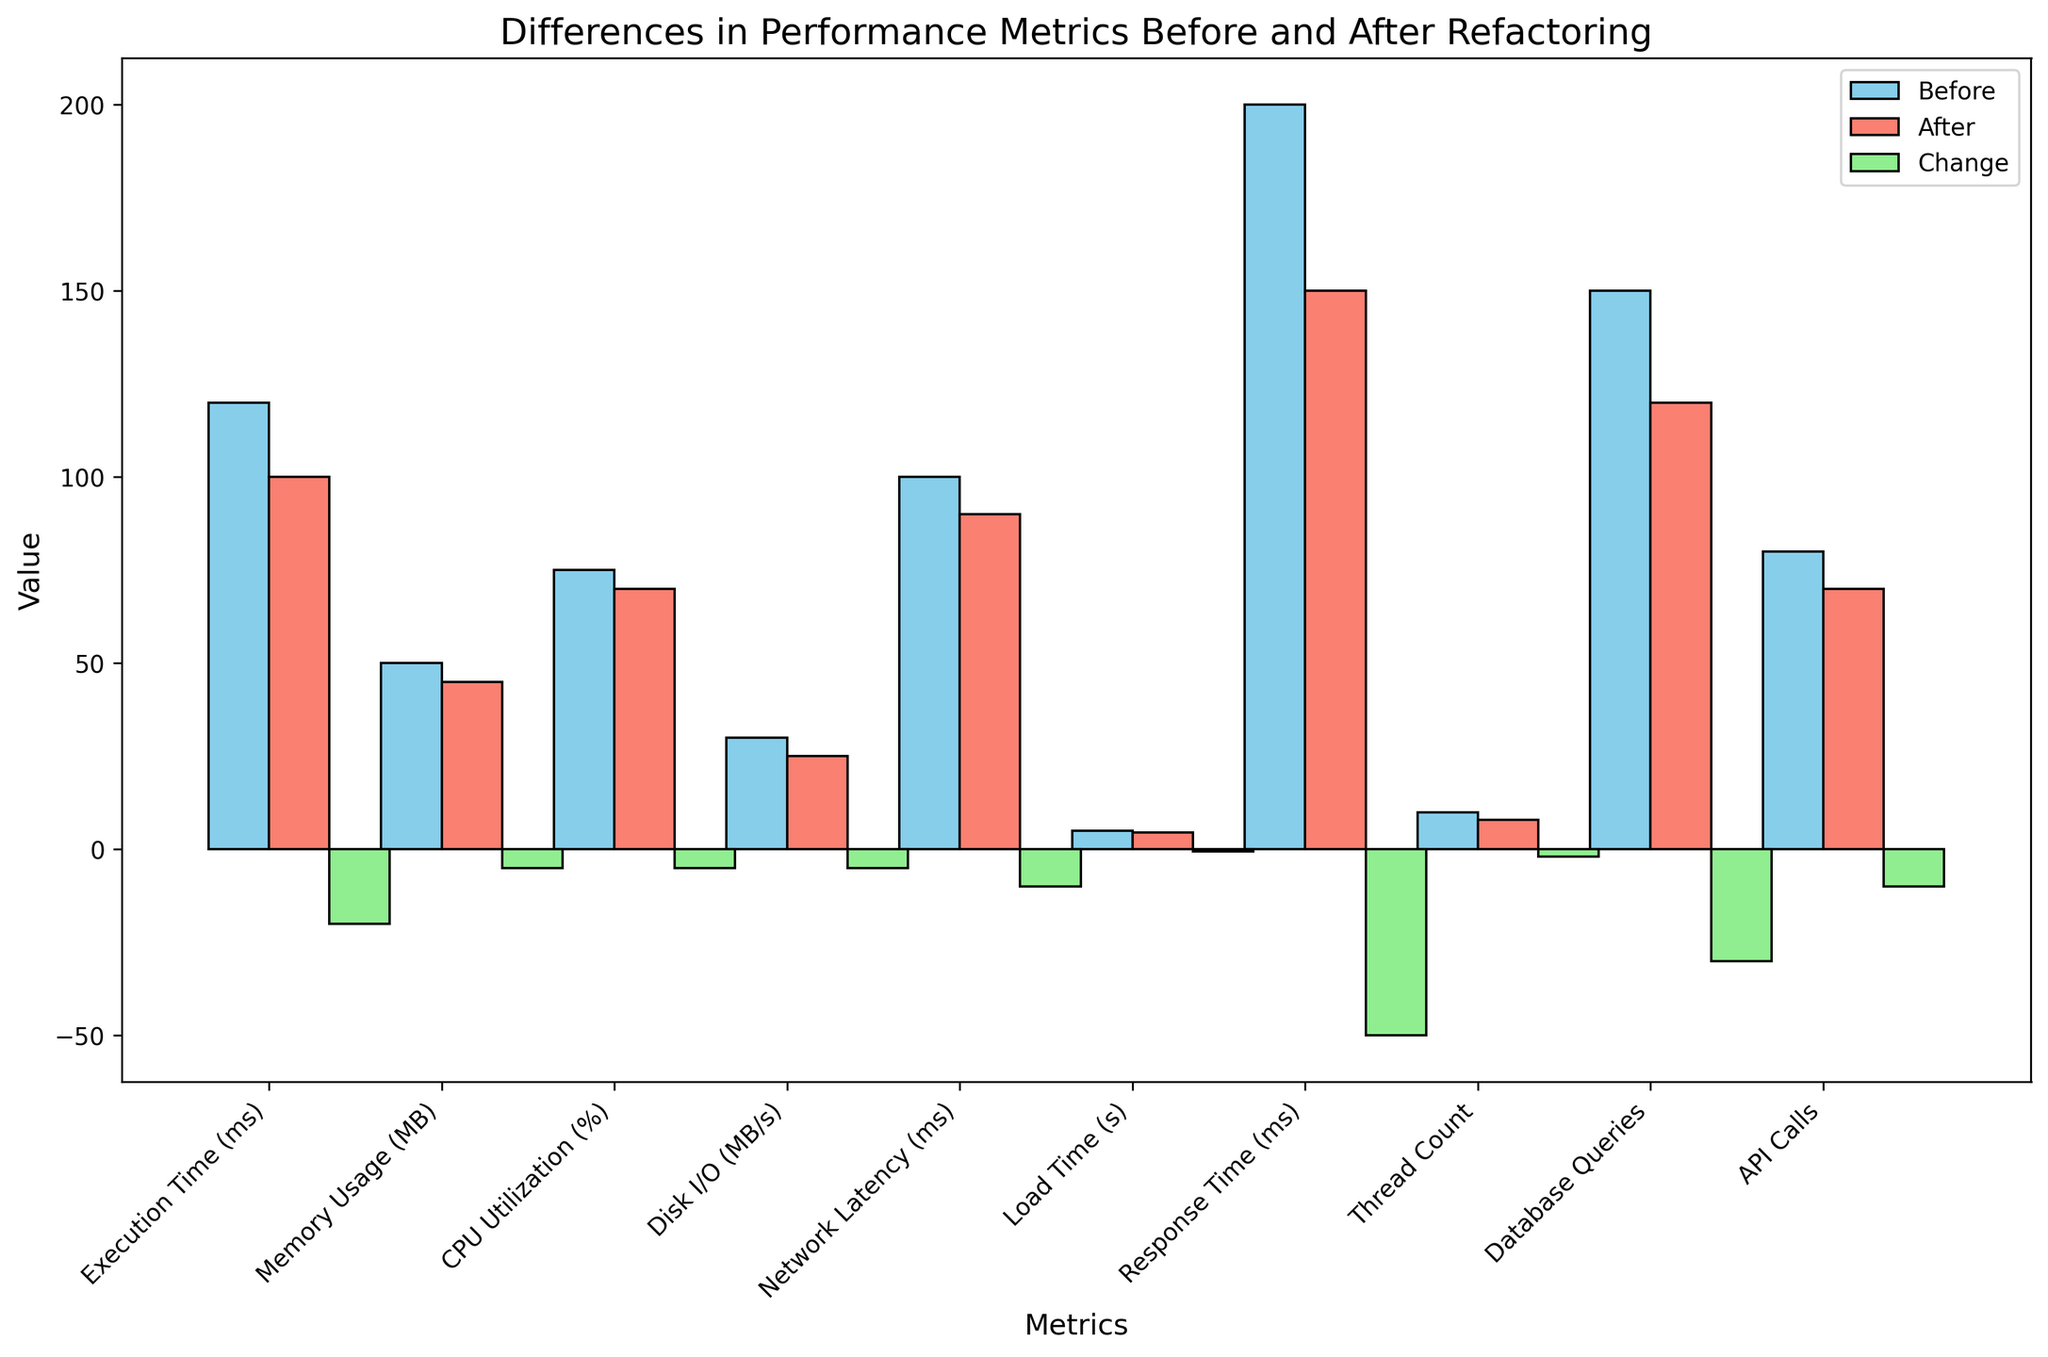Which metric showed the largest decrease in value after refactoring? To determine the largest decrease, we look at the "Change" values and identify the one with the most negative value. "Response Time" has the largest negative change of -50.
Answer: Response Time What is the combined memory usage (Before and After) compared to combined API Calls (Before and After)? First, add the values for "Memory Usage" and "API Calls" before and after refactoring. Memory Usage: 50 (Before) + 45 (After) = 95, API Calls: 80 (Before) + 70 (After) = 150. Compare the two sums: 95 < 150.
Answer: API Calls are higher Which metric had the smallest change after refactoring and what was that change? To find the smallest change, look for the value with the least magnitude in the "Change" column. "Load Time" has the smallest change of -0.5.
Answer: Load Time, -0.5 Are there any metrics that have the same change value? Identify metrics with identical "Change" values. Both "Memory Usage," "CPU Utilization," and "Disk I/O" have a change value of -5.
Answer: Memory Usage, CPU Utilization, Disk I/O How does the CPU Utilization change compare to the Disk I/O change? Observe the "Change" values of "CPU Utilization" and "Disk I/O." Both have a change of -5, indicating an equal decrease.
Answer: Equal What is the average change across all metrics? To find the average change, sum up all "Change" values and divide by the number of metrics. Sum: -20 + -5 + -5 + -5 + -10 + -0.5 + -50 + -2 + -30 + -10 = -137.5. Number of metrics: 10. Average change = -137.5 / 10 = -13.75.
Answer: -13.75 Which colored bar represents the "Before" values in the chart? By looking at the color legend in the chart, it shows that the "Before" values are represented by the skyblue bars.
Answer: Skyblue Which metric saw a decrease in execution time, and by how much did it decrease? To find the decrease in execution time, look at the "Execution Time" metric and its "Change" value, which is -20 ms.
Answer: Execution Time, -20 Is the decrease in database queries larger than all other changes? Compare the "Change" value for "Database Queries" (-30) with other metrics changes. Though it's large, "Response Time" has a larger decrease (-50).
Answer: No How much total improvement was made in terms of Execution Time and Response Time combined? Sum the "Change" values for "Execution Time" and "Response Time." Execution Time: -20, Response Time: -50. Combined improvement: -20 + -50 = -70.
Answer: -70 